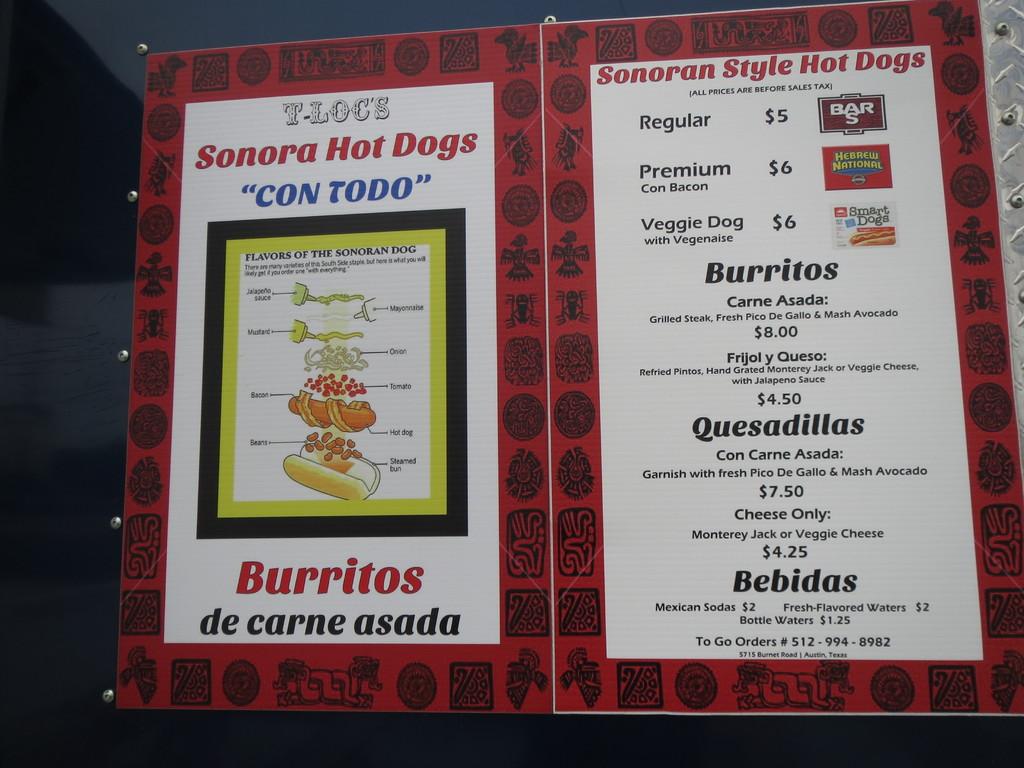Does this place sell hot dogs?
Your answer should be compact. Yes. This is library?
Provide a succinct answer. No. 